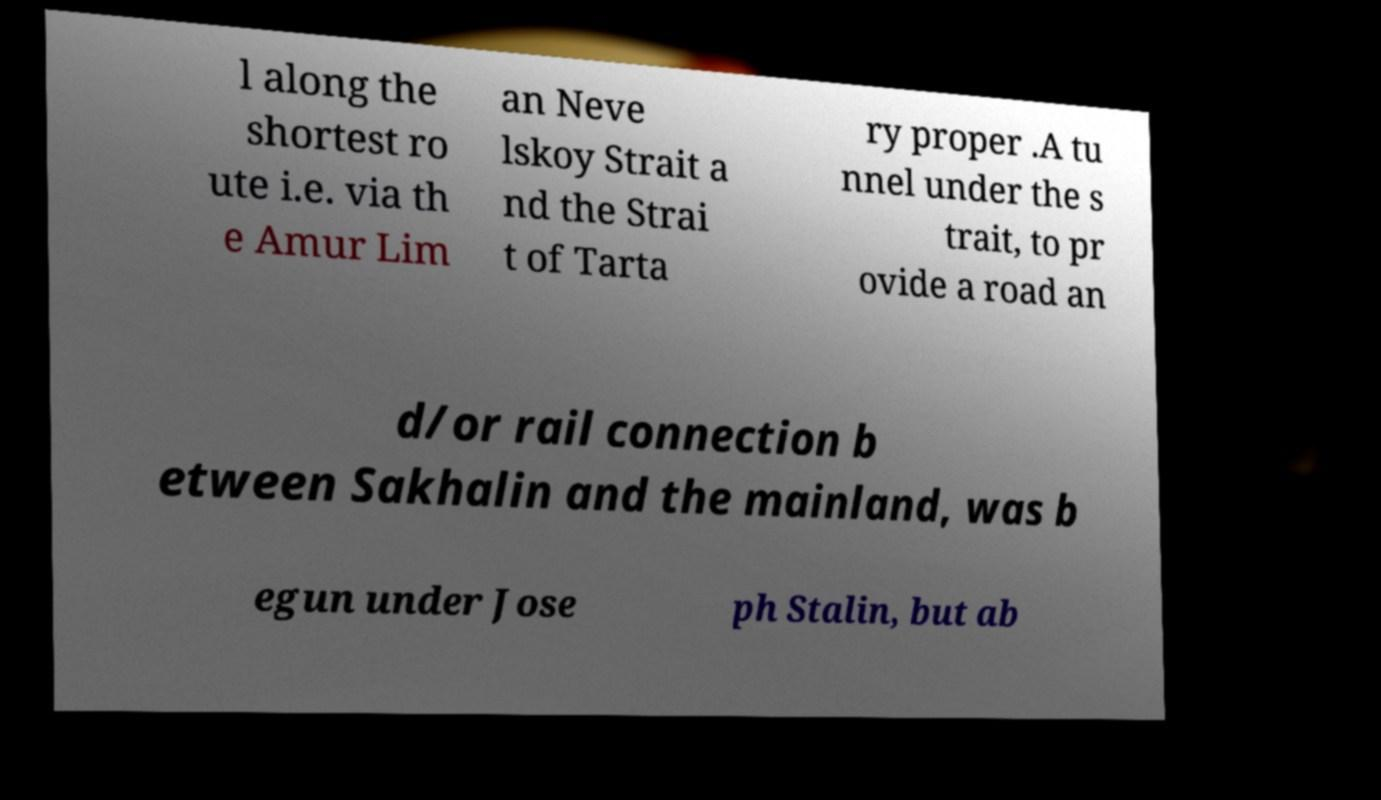Please read and relay the text visible in this image. What does it say? l along the shortest ro ute i.e. via th e Amur Lim an Neve lskoy Strait a nd the Strai t of Tarta ry proper .A tu nnel under the s trait, to pr ovide a road an d/or rail connection b etween Sakhalin and the mainland, was b egun under Jose ph Stalin, but ab 